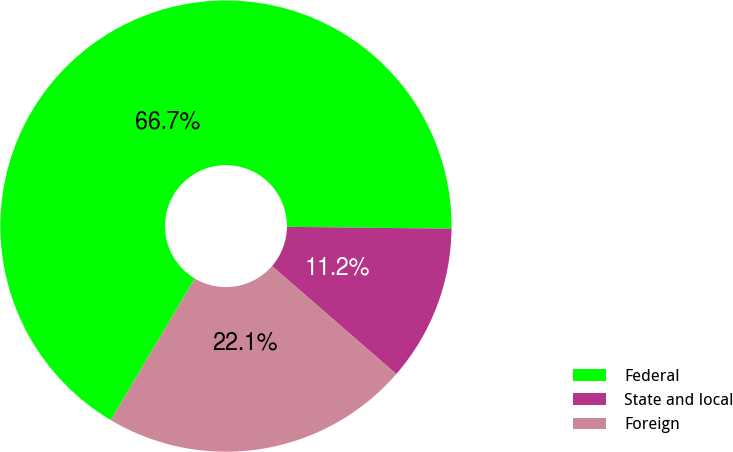Convert chart. <chart><loc_0><loc_0><loc_500><loc_500><pie_chart><fcel>Federal<fcel>State and local<fcel>Foreign<nl><fcel>66.67%<fcel>11.2%<fcel>22.14%<nl></chart> 